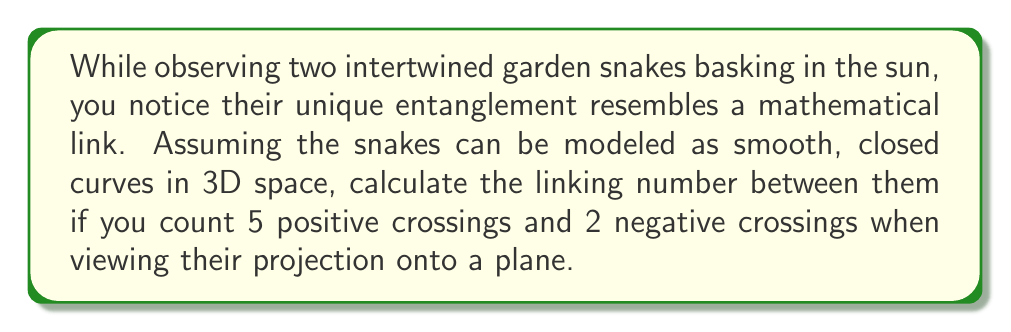Can you solve this math problem? To solve this problem, we'll follow these steps:

1. Understand the concept of linking number:
   The linking number is a topological invariant that measures how two closed curves are linked in three-dimensional space.

2. Recall the formula for linking number:
   $$Lk = \frac{1}{2}\sum_{i} \epsilon_i$$
   where $\epsilon_i$ is the sign of each crossing (+1 for positive, -1 for negative).

3. Count the crossings:
   - Positive crossings: 5
   - Negative crossings: 2

4. Assign values to each crossing:
   - 5 positive crossings: $5 \times (+1) = +5$
   - 2 negative crossings: $2 \times (-1) = -2$

5. Sum all crossing values:
   $\sum_{i} \epsilon_i = (+5) + (-2) = +3$

6. Apply the linking number formula:
   $$Lk = \frac{1}{2}(+3) = \frac{3}{2} = 1.5$$

The linking number is always an integer or half-integer, so 1.5 is a valid result.
Answer: $\frac{3}{2}$ or 1.5 